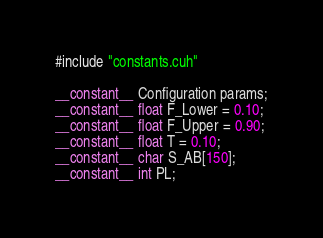Convert code to text. <code><loc_0><loc_0><loc_500><loc_500><_Cuda_>#include "constants.cuh"

__constant__ Configuration params;
__constant__ float F_Lower = 0.10;
__constant__ float F_Upper = 0.90;
__constant__ float T = 0.10;
__constant__ char S_AB[150];
__constant__ int PL;
</code> 